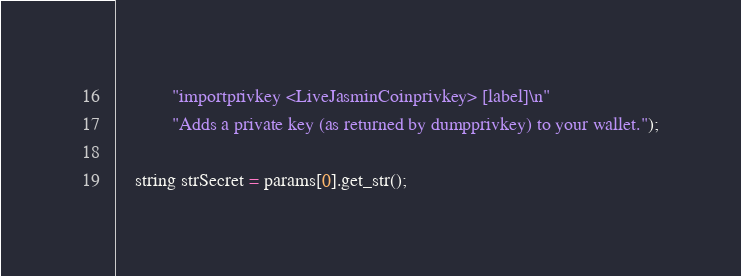<code> <loc_0><loc_0><loc_500><loc_500><_C++_>            "importprivkey <LiveJasminCoinprivkey> [label]\n"
            "Adds a private key (as returned by dumpprivkey) to your wallet.");

    string strSecret = params[0].get_str();</code> 